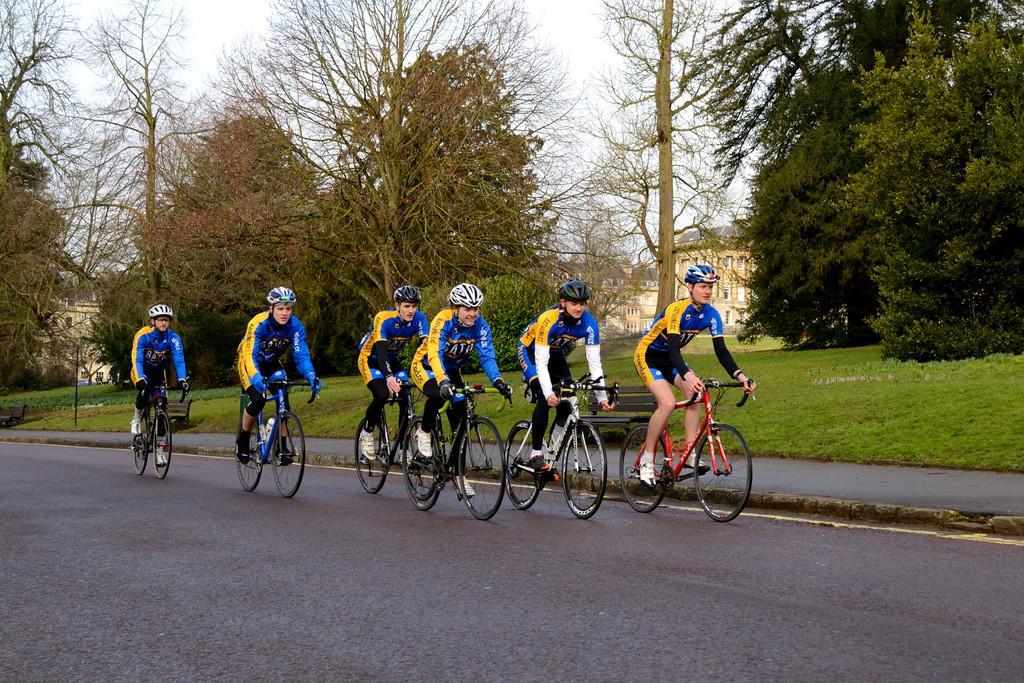Could you give a brief overview of what you see in this image? The picture is on a road. There are few people riding cycle they all are wearing blue jacket and helmet. In the background there are trees and building. 